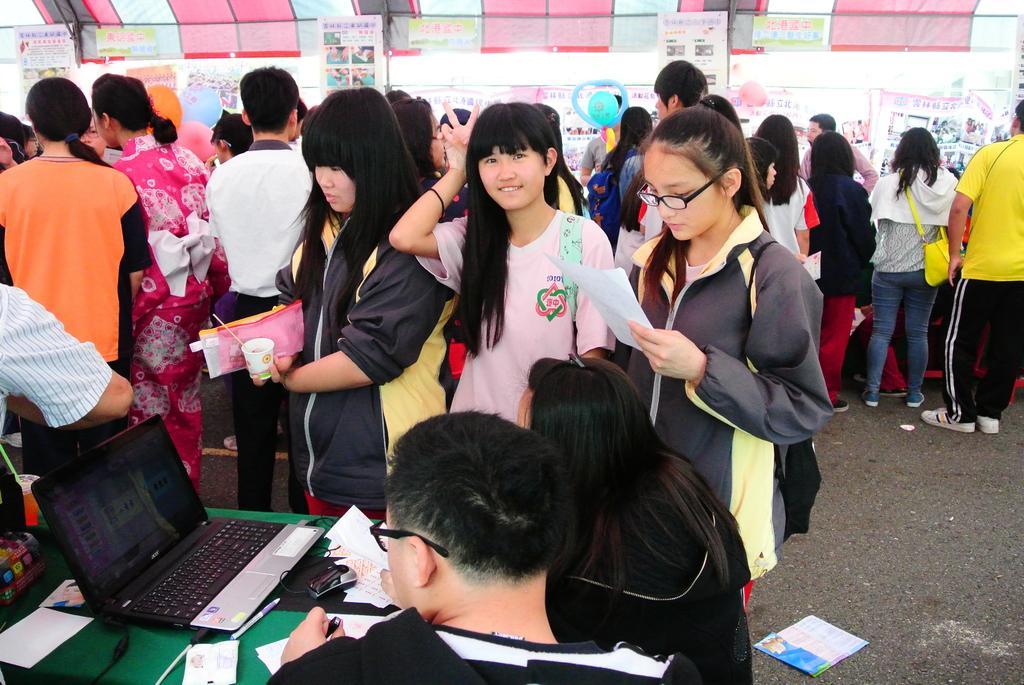In one or two sentences, can you explain what this image depicts? In this image I can see group of people. Also there is a table and on table there is a laptop, also there are pens,papers and some other objects on it. 